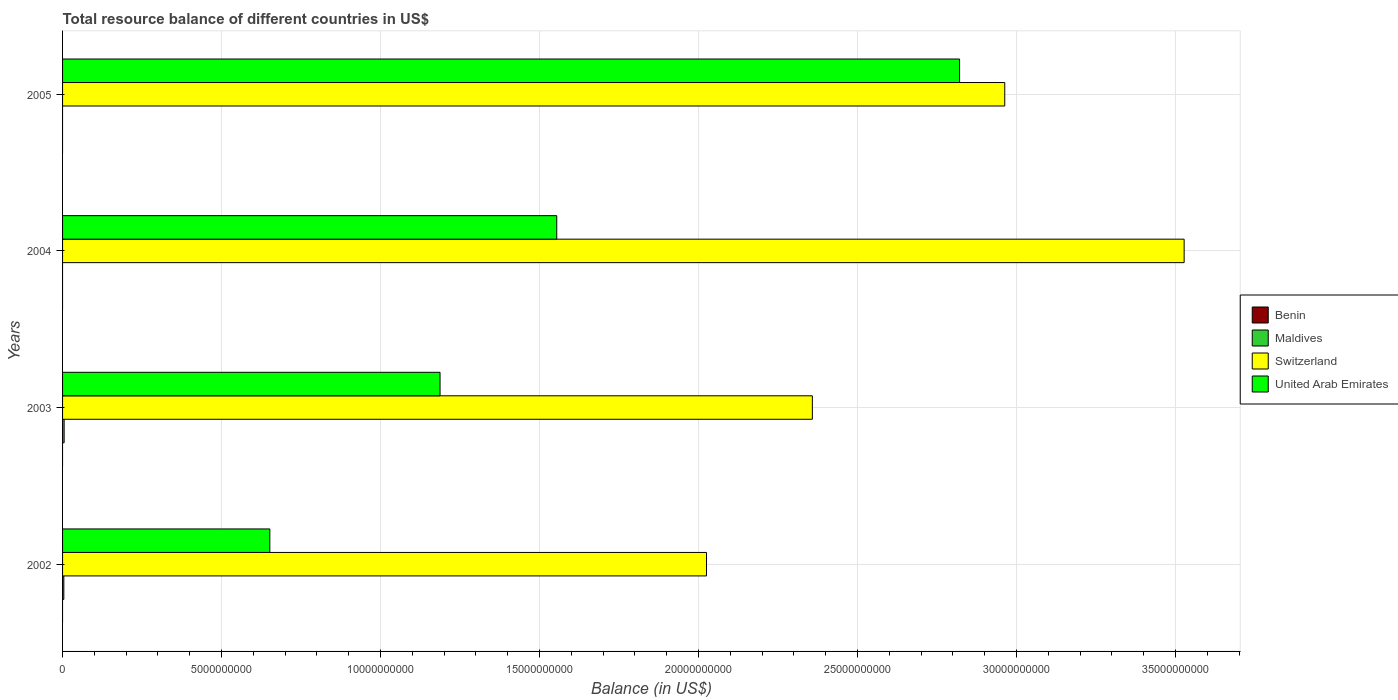How many different coloured bars are there?
Your answer should be compact. 3. Are the number of bars on each tick of the Y-axis equal?
Your answer should be very brief. No. How many bars are there on the 1st tick from the top?
Offer a terse response. 2. How many bars are there on the 2nd tick from the bottom?
Make the answer very short. 3. In how many cases, is the number of bars for a given year not equal to the number of legend labels?
Your answer should be compact. 4. What is the total resource balance in United Arab Emirates in 2004?
Your answer should be compact. 1.55e+1. Across all years, what is the maximum total resource balance in United Arab Emirates?
Ensure brevity in your answer.  2.82e+1. Across all years, what is the minimum total resource balance in United Arab Emirates?
Your answer should be very brief. 6.52e+09. What is the total total resource balance in United Arab Emirates in the graph?
Your response must be concise. 6.21e+1. What is the difference between the total resource balance in United Arab Emirates in 2003 and that in 2004?
Keep it short and to the point. -3.67e+09. What is the difference between the total resource balance in Switzerland in 2004 and the total resource balance in Benin in 2005?
Ensure brevity in your answer.  3.53e+1. What is the average total resource balance in Switzerland per year?
Make the answer very short. 2.72e+1. In the year 2005, what is the difference between the total resource balance in United Arab Emirates and total resource balance in Switzerland?
Your answer should be very brief. -1.42e+09. In how many years, is the total resource balance in United Arab Emirates greater than 5000000000 US$?
Give a very brief answer. 4. What is the ratio of the total resource balance in Switzerland in 2003 to that in 2004?
Make the answer very short. 0.67. Is the total resource balance in Switzerland in 2003 less than that in 2004?
Give a very brief answer. Yes. What is the difference between the highest and the second highest total resource balance in United Arab Emirates?
Make the answer very short. 1.27e+1. What is the difference between the highest and the lowest total resource balance in Maldives?
Keep it short and to the point. 4.94e+07. Is it the case that in every year, the sum of the total resource balance in United Arab Emirates and total resource balance in Switzerland is greater than the sum of total resource balance in Benin and total resource balance in Maldives?
Keep it short and to the point. No. Is it the case that in every year, the sum of the total resource balance in Maldives and total resource balance in United Arab Emirates is greater than the total resource balance in Switzerland?
Ensure brevity in your answer.  No. How many bars are there?
Give a very brief answer. 10. Are all the bars in the graph horizontal?
Your answer should be compact. Yes. What is the difference between two consecutive major ticks on the X-axis?
Ensure brevity in your answer.  5.00e+09. Does the graph contain grids?
Give a very brief answer. Yes. Where does the legend appear in the graph?
Ensure brevity in your answer.  Center right. How many legend labels are there?
Offer a very short reply. 4. What is the title of the graph?
Make the answer very short. Total resource balance of different countries in US$. Does "New Zealand" appear as one of the legend labels in the graph?
Make the answer very short. No. What is the label or title of the X-axis?
Your answer should be compact. Balance (in US$). What is the label or title of the Y-axis?
Offer a terse response. Years. What is the Balance (in US$) in Maldives in 2002?
Your answer should be compact. 3.95e+07. What is the Balance (in US$) in Switzerland in 2002?
Give a very brief answer. 2.02e+1. What is the Balance (in US$) in United Arab Emirates in 2002?
Provide a succinct answer. 6.52e+09. What is the Balance (in US$) in Maldives in 2003?
Offer a terse response. 4.94e+07. What is the Balance (in US$) of Switzerland in 2003?
Your answer should be very brief. 2.36e+1. What is the Balance (in US$) in United Arab Emirates in 2003?
Keep it short and to the point. 1.19e+1. What is the Balance (in US$) in Maldives in 2004?
Your response must be concise. 0. What is the Balance (in US$) in Switzerland in 2004?
Make the answer very short. 3.53e+1. What is the Balance (in US$) of United Arab Emirates in 2004?
Ensure brevity in your answer.  1.55e+1. What is the Balance (in US$) in Maldives in 2005?
Your answer should be compact. 0. What is the Balance (in US$) of Switzerland in 2005?
Make the answer very short. 2.96e+1. What is the Balance (in US$) in United Arab Emirates in 2005?
Offer a very short reply. 2.82e+1. Across all years, what is the maximum Balance (in US$) in Maldives?
Your response must be concise. 4.94e+07. Across all years, what is the maximum Balance (in US$) of Switzerland?
Keep it short and to the point. 3.53e+1. Across all years, what is the maximum Balance (in US$) in United Arab Emirates?
Keep it short and to the point. 2.82e+1. Across all years, what is the minimum Balance (in US$) of Switzerland?
Your response must be concise. 2.02e+1. Across all years, what is the minimum Balance (in US$) of United Arab Emirates?
Give a very brief answer. 6.52e+09. What is the total Balance (in US$) of Benin in the graph?
Your answer should be compact. 0. What is the total Balance (in US$) in Maldives in the graph?
Offer a terse response. 8.88e+07. What is the total Balance (in US$) of Switzerland in the graph?
Make the answer very short. 1.09e+11. What is the total Balance (in US$) of United Arab Emirates in the graph?
Your answer should be compact. 6.21e+1. What is the difference between the Balance (in US$) of Maldives in 2002 and that in 2003?
Keep it short and to the point. -9.92e+06. What is the difference between the Balance (in US$) in Switzerland in 2002 and that in 2003?
Your response must be concise. -3.33e+09. What is the difference between the Balance (in US$) of United Arab Emirates in 2002 and that in 2003?
Ensure brevity in your answer.  -5.35e+09. What is the difference between the Balance (in US$) of Switzerland in 2002 and that in 2004?
Ensure brevity in your answer.  -1.50e+1. What is the difference between the Balance (in US$) in United Arab Emirates in 2002 and that in 2004?
Your answer should be very brief. -9.02e+09. What is the difference between the Balance (in US$) of Switzerland in 2002 and that in 2005?
Offer a terse response. -9.38e+09. What is the difference between the Balance (in US$) in United Arab Emirates in 2002 and that in 2005?
Offer a terse response. -2.17e+1. What is the difference between the Balance (in US$) of Switzerland in 2003 and that in 2004?
Provide a succinct answer. -1.17e+1. What is the difference between the Balance (in US$) in United Arab Emirates in 2003 and that in 2004?
Your response must be concise. -3.67e+09. What is the difference between the Balance (in US$) in Switzerland in 2003 and that in 2005?
Your response must be concise. -6.05e+09. What is the difference between the Balance (in US$) in United Arab Emirates in 2003 and that in 2005?
Your response must be concise. -1.63e+1. What is the difference between the Balance (in US$) in Switzerland in 2004 and that in 2005?
Offer a terse response. 5.64e+09. What is the difference between the Balance (in US$) in United Arab Emirates in 2004 and that in 2005?
Give a very brief answer. -1.27e+1. What is the difference between the Balance (in US$) in Maldives in 2002 and the Balance (in US$) in Switzerland in 2003?
Provide a succinct answer. -2.35e+1. What is the difference between the Balance (in US$) in Maldives in 2002 and the Balance (in US$) in United Arab Emirates in 2003?
Your answer should be compact. -1.18e+1. What is the difference between the Balance (in US$) in Switzerland in 2002 and the Balance (in US$) in United Arab Emirates in 2003?
Your answer should be very brief. 8.38e+09. What is the difference between the Balance (in US$) of Maldives in 2002 and the Balance (in US$) of Switzerland in 2004?
Provide a succinct answer. -3.52e+1. What is the difference between the Balance (in US$) in Maldives in 2002 and the Balance (in US$) in United Arab Emirates in 2004?
Offer a very short reply. -1.55e+1. What is the difference between the Balance (in US$) of Switzerland in 2002 and the Balance (in US$) of United Arab Emirates in 2004?
Your response must be concise. 4.71e+09. What is the difference between the Balance (in US$) of Maldives in 2002 and the Balance (in US$) of Switzerland in 2005?
Your answer should be compact. -2.96e+1. What is the difference between the Balance (in US$) in Maldives in 2002 and the Balance (in US$) in United Arab Emirates in 2005?
Provide a short and direct response. -2.82e+1. What is the difference between the Balance (in US$) of Switzerland in 2002 and the Balance (in US$) of United Arab Emirates in 2005?
Offer a very short reply. -7.96e+09. What is the difference between the Balance (in US$) in Maldives in 2003 and the Balance (in US$) in Switzerland in 2004?
Your answer should be very brief. -3.52e+1. What is the difference between the Balance (in US$) of Maldives in 2003 and the Balance (in US$) of United Arab Emirates in 2004?
Your response must be concise. -1.55e+1. What is the difference between the Balance (in US$) in Switzerland in 2003 and the Balance (in US$) in United Arab Emirates in 2004?
Your answer should be very brief. 8.04e+09. What is the difference between the Balance (in US$) of Maldives in 2003 and the Balance (in US$) of Switzerland in 2005?
Ensure brevity in your answer.  -2.96e+1. What is the difference between the Balance (in US$) in Maldives in 2003 and the Balance (in US$) in United Arab Emirates in 2005?
Your answer should be compact. -2.82e+1. What is the difference between the Balance (in US$) of Switzerland in 2003 and the Balance (in US$) of United Arab Emirates in 2005?
Make the answer very short. -4.63e+09. What is the difference between the Balance (in US$) in Switzerland in 2004 and the Balance (in US$) in United Arab Emirates in 2005?
Your response must be concise. 7.06e+09. What is the average Balance (in US$) in Benin per year?
Keep it short and to the point. 0. What is the average Balance (in US$) of Maldives per year?
Ensure brevity in your answer.  2.22e+07. What is the average Balance (in US$) of Switzerland per year?
Make the answer very short. 2.72e+1. What is the average Balance (in US$) in United Arab Emirates per year?
Give a very brief answer. 1.55e+1. In the year 2002, what is the difference between the Balance (in US$) in Maldives and Balance (in US$) in Switzerland?
Ensure brevity in your answer.  -2.02e+1. In the year 2002, what is the difference between the Balance (in US$) of Maldives and Balance (in US$) of United Arab Emirates?
Ensure brevity in your answer.  -6.48e+09. In the year 2002, what is the difference between the Balance (in US$) in Switzerland and Balance (in US$) in United Arab Emirates?
Your response must be concise. 1.37e+1. In the year 2003, what is the difference between the Balance (in US$) in Maldives and Balance (in US$) in Switzerland?
Your response must be concise. -2.35e+1. In the year 2003, what is the difference between the Balance (in US$) of Maldives and Balance (in US$) of United Arab Emirates?
Your answer should be very brief. -1.18e+1. In the year 2003, what is the difference between the Balance (in US$) of Switzerland and Balance (in US$) of United Arab Emirates?
Offer a very short reply. 1.17e+1. In the year 2004, what is the difference between the Balance (in US$) in Switzerland and Balance (in US$) in United Arab Emirates?
Your answer should be compact. 1.97e+1. In the year 2005, what is the difference between the Balance (in US$) of Switzerland and Balance (in US$) of United Arab Emirates?
Offer a very short reply. 1.42e+09. What is the ratio of the Balance (in US$) in Maldives in 2002 to that in 2003?
Give a very brief answer. 0.8. What is the ratio of the Balance (in US$) of Switzerland in 2002 to that in 2003?
Offer a very short reply. 0.86. What is the ratio of the Balance (in US$) in United Arab Emirates in 2002 to that in 2003?
Provide a short and direct response. 0.55. What is the ratio of the Balance (in US$) of Switzerland in 2002 to that in 2004?
Ensure brevity in your answer.  0.57. What is the ratio of the Balance (in US$) in United Arab Emirates in 2002 to that in 2004?
Provide a short and direct response. 0.42. What is the ratio of the Balance (in US$) of Switzerland in 2002 to that in 2005?
Offer a very short reply. 0.68. What is the ratio of the Balance (in US$) of United Arab Emirates in 2002 to that in 2005?
Make the answer very short. 0.23. What is the ratio of the Balance (in US$) of Switzerland in 2003 to that in 2004?
Give a very brief answer. 0.67. What is the ratio of the Balance (in US$) of United Arab Emirates in 2003 to that in 2004?
Ensure brevity in your answer.  0.76. What is the ratio of the Balance (in US$) in Switzerland in 2003 to that in 2005?
Offer a terse response. 0.8. What is the ratio of the Balance (in US$) in United Arab Emirates in 2003 to that in 2005?
Offer a very short reply. 0.42. What is the ratio of the Balance (in US$) of Switzerland in 2004 to that in 2005?
Provide a short and direct response. 1.19. What is the ratio of the Balance (in US$) in United Arab Emirates in 2004 to that in 2005?
Offer a terse response. 0.55. What is the difference between the highest and the second highest Balance (in US$) in Switzerland?
Offer a terse response. 5.64e+09. What is the difference between the highest and the second highest Balance (in US$) of United Arab Emirates?
Offer a very short reply. 1.27e+1. What is the difference between the highest and the lowest Balance (in US$) in Maldives?
Offer a very short reply. 4.94e+07. What is the difference between the highest and the lowest Balance (in US$) in Switzerland?
Offer a terse response. 1.50e+1. What is the difference between the highest and the lowest Balance (in US$) in United Arab Emirates?
Ensure brevity in your answer.  2.17e+1. 